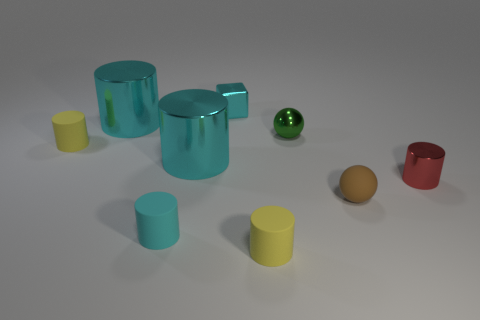There is a small yellow rubber cylinder that is in front of the yellow rubber cylinder that is behind the tiny red shiny cylinder; how many tiny rubber things are on the left side of it?
Provide a short and direct response. 2. Is the number of yellow things that are in front of the small brown rubber sphere greater than the number of cyan cylinders behind the red shiny object?
Your response must be concise. No. What number of small gray things are the same shape as the brown thing?
Give a very brief answer. 0. How many objects are cylinders behind the green metallic object or cyan objects that are behind the tiny matte ball?
Your answer should be very brief. 3. What material is the yellow cylinder that is on the left side of the rubber thing in front of the small cyan thing in front of the metallic ball?
Your answer should be very brief. Rubber. Is the color of the ball that is in front of the tiny red object the same as the small metal block?
Your answer should be very brief. No. There is a cyan thing that is right of the cyan matte object and in front of the metallic block; what material is it?
Offer a terse response. Metal. Are there any blocks of the same size as the green shiny ball?
Ensure brevity in your answer.  Yes. What number of tiny red matte spheres are there?
Keep it short and to the point. 0. What number of small metal cylinders are in front of the cyan matte object?
Your answer should be compact. 0. 